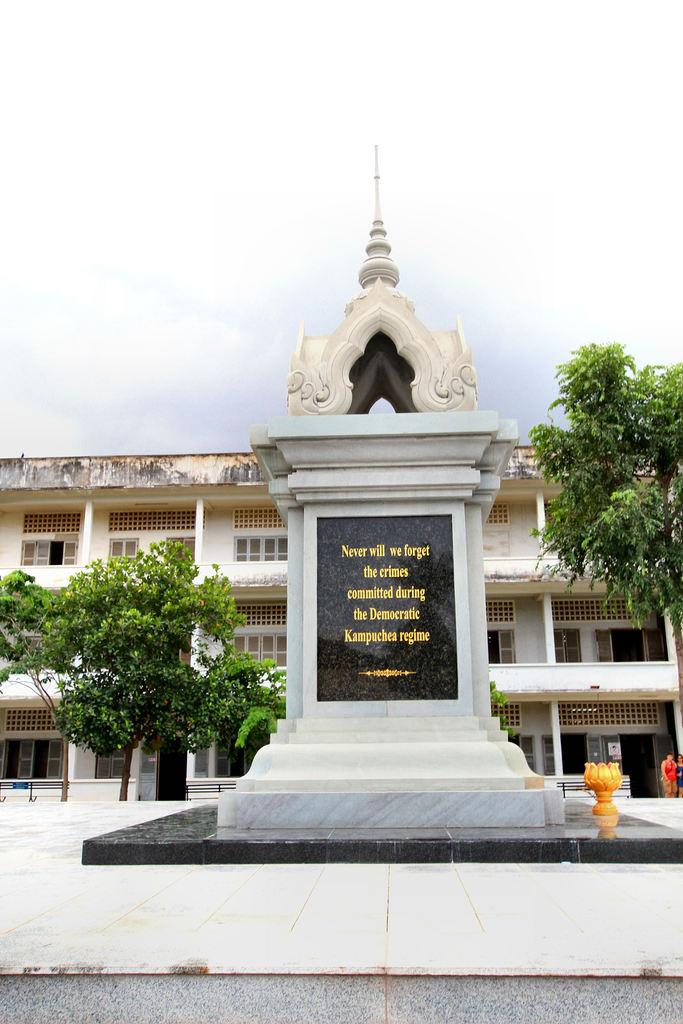<image>
Offer a succinct explanation of the picture presented. A monument outside a building commemorates crimes committed during the Kampuchea Regime. 